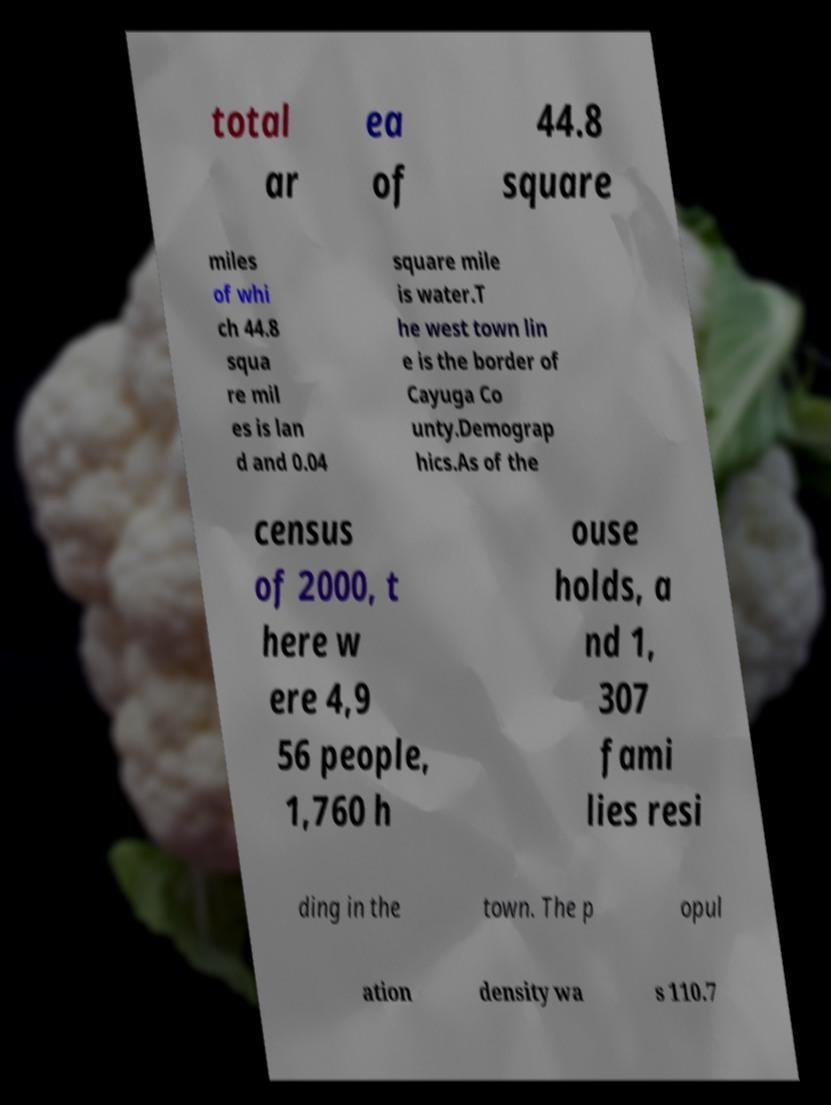Can you accurately transcribe the text from the provided image for me? total ar ea of 44.8 square miles of whi ch 44.8 squa re mil es is lan d and 0.04 square mile is water.T he west town lin e is the border of Cayuga Co unty.Demograp hics.As of the census of 2000, t here w ere 4,9 56 people, 1,760 h ouse holds, a nd 1, 307 fami lies resi ding in the town. The p opul ation density wa s 110.7 